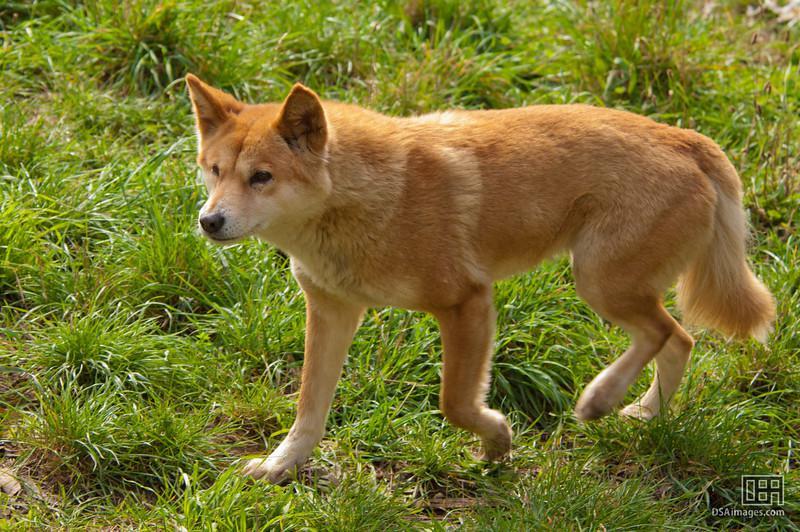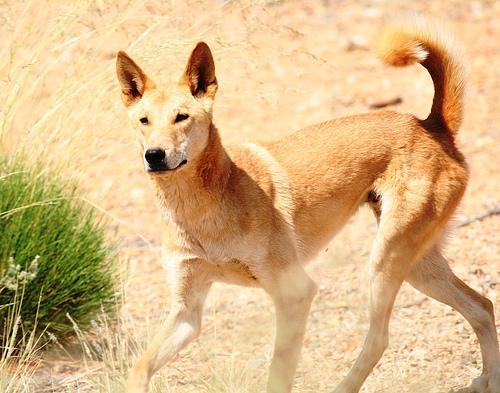The first image is the image on the left, the second image is the image on the right. Examine the images to the left and right. Is the description "A dog is walking through the grass in one of the images." accurate? Answer yes or no. Yes. The first image is the image on the left, the second image is the image on the right. For the images shown, is this caption "An image shows one wild dog walking leftward across green grass." true? Answer yes or no. Yes. 